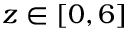Convert formula to latex. <formula><loc_0><loc_0><loc_500><loc_500>z \in [ 0 , 6 ]</formula> 